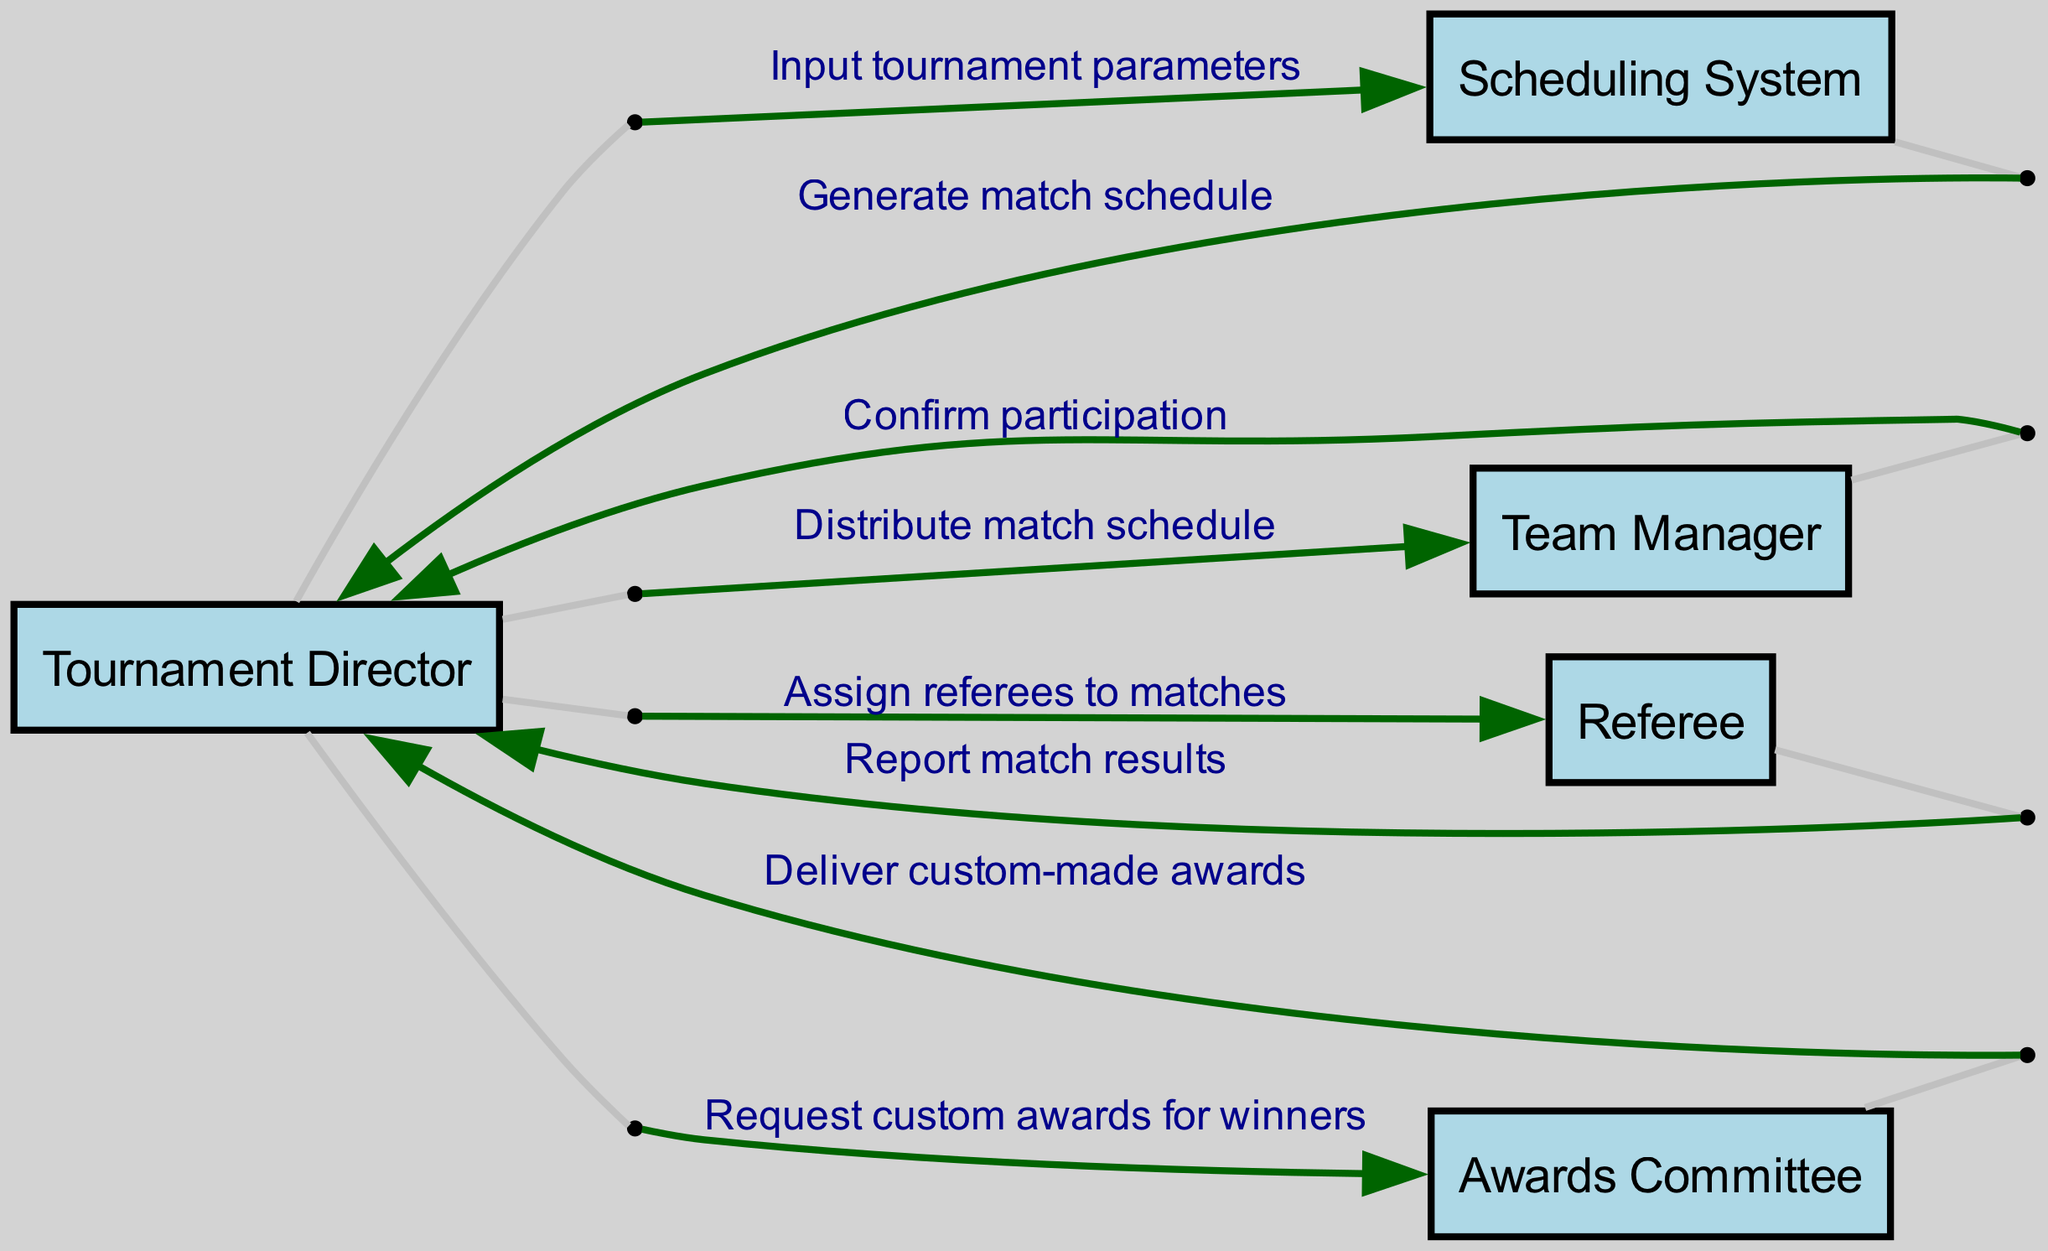What is the first action taken in the sequence? The first action, as shown in the sequence diagram, is initiated by the Tournament Director who inputs tournament parameters into the Scheduling System.
Answer: Input tournament parameters How many actors are involved in the tournament organization process? The diagram includes five distinct actors: Tournament Director, Scheduling System, Team Manager, Referee, and Awards Committee.
Answer: Five What message is sent from the Scheduling System back to the Tournament Director? The Scheduling System sends a message back to the Tournament Director, specifically to generate a match schedule after the tournament parameters are inputted.
Answer: Generate match schedule Which actor is responsible for delivering custom awards? The Awards Committee is responsible for delivering the custom-made awards as indicated in the last part of the sequence.
Answer: Awards Committee What is the last interaction in the sequence diagram? The last interaction occurs when the Awards Committee delivers the custom-made awards to the Tournament Director, completing the award process.
Answer: Deliver custom-made awards How many messages are exchanged between the Tournament Director and the Team Manager? There are two messages exchanged between the Tournament Director and the Team Manager: one for distributing the match schedule and another for confirming participation.
Answer: Two 